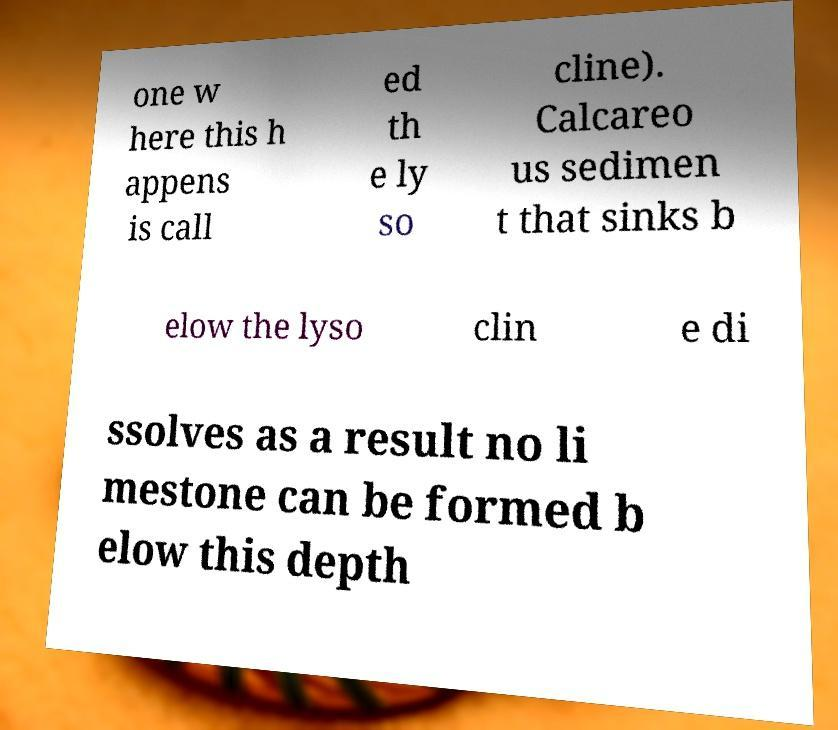Could you extract and type out the text from this image? one w here this h appens is call ed th e ly so cline). Calcareo us sedimen t that sinks b elow the lyso clin e di ssolves as a result no li mestone can be formed b elow this depth 